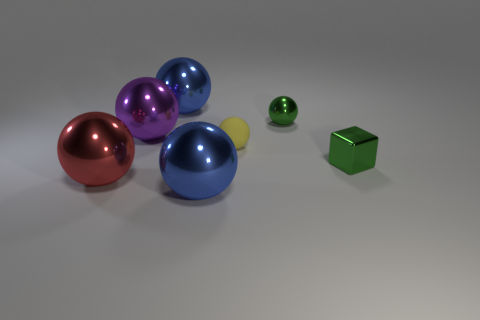Is the shape of the tiny metallic object to the left of the green block the same as the small metal object right of the tiny green metal ball?
Keep it short and to the point. No. There is a ball that is both in front of the purple thing and behind the large red shiny ball; how big is it?
Provide a short and direct response. Small. There is another small metallic object that is the same shape as the tiny yellow thing; what is its color?
Make the answer very short. Green. There is a shiny ball that is right of the thing that is in front of the big red shiny thing; what is its color?
Offer a terse response. Green. What shape is the purple shiny object?
Your answer should be compact. Sphere. The big metal object that is both in front of the large purple metallic ball and on the right side of the red thing has what shape?
Your answer should be very brief. Sphere. There is a tiny cube that is made of the same material as the purple thing; what is its color?
Ensure brevity in your answer.  Green. What is the shape of the large blue thing behind the large metallic sphere that is on the right side of the blue object that is behind the red ball?
Your answer should be very brief. Sphere. What is the size of the purple metallic thing?
Give a very brief answer. Large. There is a large red object that is the same material as the green ball; what shape is it?
Make the answer very short. Sphere. 